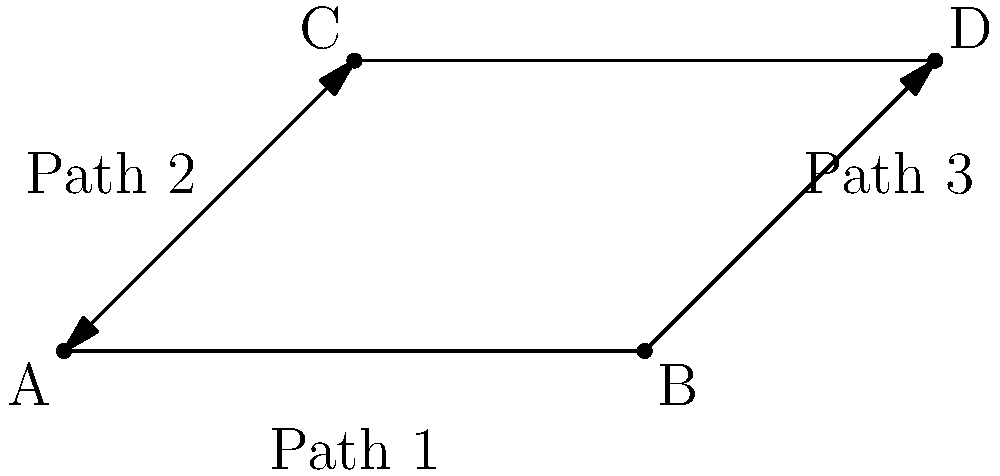In the network diagram above, you need to design a redundant path from node A to node D for fault tolerance. What is the minimum number of independent paths required to ensure connectivity between A and D if any single link fails? To determine the minimum number of independent paths required for fault tolerance:

1. Identify all possible paths from A to D:
   - Path 1: A -> B -> D
   - Path 2: A -> C -> D
   - Path 3: A -> C -> B -> D

2. Consider the impact of a single link failure:
   - If A-B fails, paths 2 and 3 are still available
   - If B-D fails, paths 2 and 3 are still available
   - If A-C fails, path 1 is still available
   - If C-D fails, paths 1 and 3 are still available
   - If C-B fails, paths 1 and 2 are still available

3. Analyze the minimum number of paths needed:
   - We need at least 2 independent paths to ensure connectivity if any single link fails
   - Path 1 (A -> B -> D) and Path 2 (A -> C -> D) are sufficient

4. Verify the solution:
   - With paths 1 and 2, if any single link fails, there's always an alternative path available

Therefore, the minimum number of independent paths required is 2.
Answer: 2 independent paths 